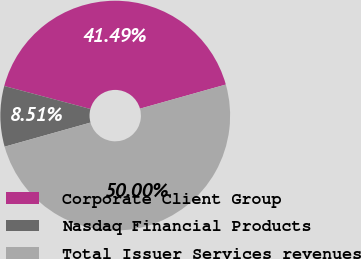Convert chart. <chart><loc_0><loc_0><loc_500><loc_500><pie_chart><fcel>Corporate Client Group<fcel>Nasdaq Financial Products<fcel>Total Issuer Services revenues<nl><fcel>41.49%<fcel>8.51%<fcel>50.0%<nl></chart> 